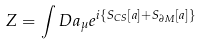Convert formula to latex. <formula><loc_0><loc_0><loc_500><loc_500>Z = \int D a _ { \mu } e ^ { i \{ S _ { C S } [ a ] + S _ { \partial M } [ a ] \} }</formula> 